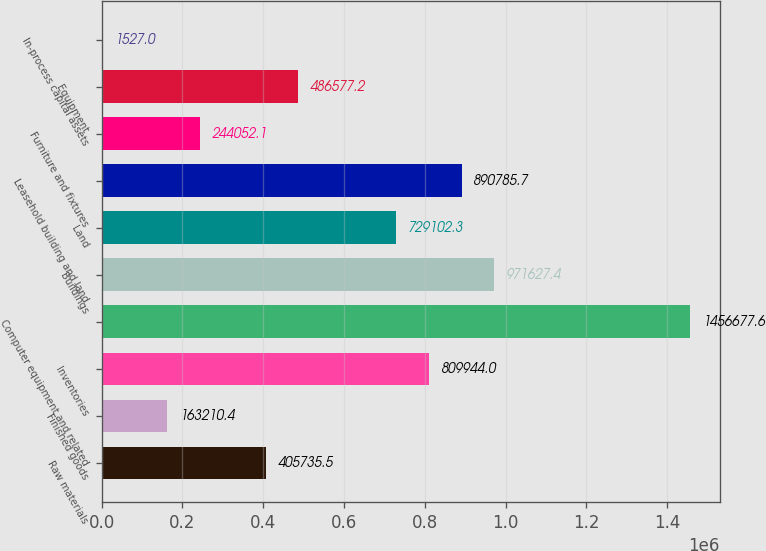Convert chart to OTSL. <chart><loc_0><loc_0><loc_500><loc_500><bar_chart><fcel>Raw materials<fcel>Finished goods<fcel>Inventories<fcel>Computer equipment and related<fcel>Buildings<fcel>Land<fcel>Leasehold building and land<fcel>Furniture and fixtures<fcel>Equipment<fcel>In-process capital assets<nl><fcel>405736<fcel>163210<fcel>809944<fcel>1.45668e+06<fcel>971627<fcel>729102<fcel>890786<fcel>244052<fcel>486577<fcel>1527<nl></chart> 